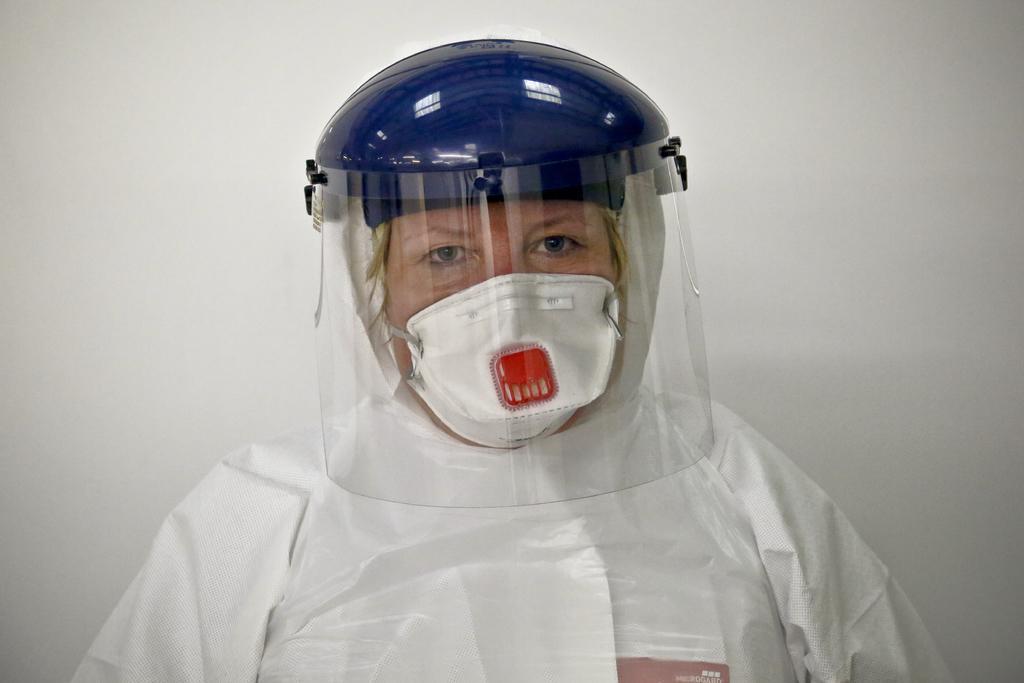How would you summarize this image in a sentence or two? In this image I can see a person wearing white color dress. I can also see a helmet in blue color and background is in white color. 